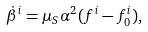Convert formula to latex. <formula><loc_0><loc_0><loc_500><loc_500>\dot { \beta } ^ { i } = \mu _ { S } \alpha ^ { 2 } ( f ^ { i } - f ^ { i } _ { 0 } ) ,</formula> 